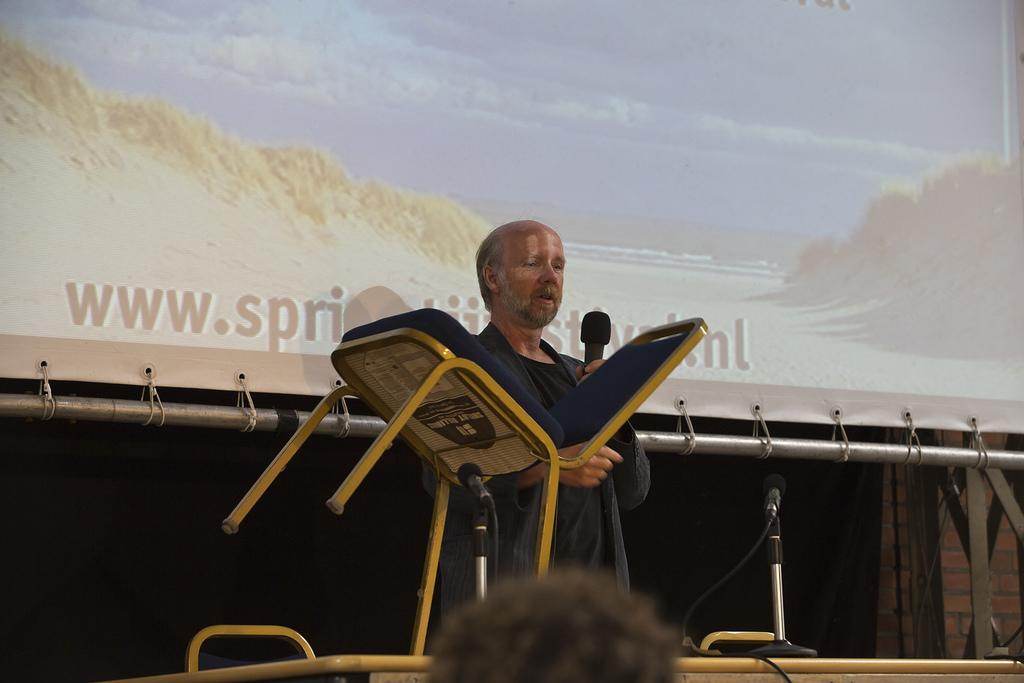What is the main subject of the image? The main subject of the image is a man. What is the man doing in the image? The man is standing, holding a chair, and talking into a microphone. What is the man holding in addition to the chair? The man is holding a microphone. What can be seen on the screen in the image? The screen displays a picture. How much money is the man holding in the image? The man is not holding any money in the image; he is holding a chair and a microphone. Is there a cave visible in the image? No, there is no cave present in the image. 